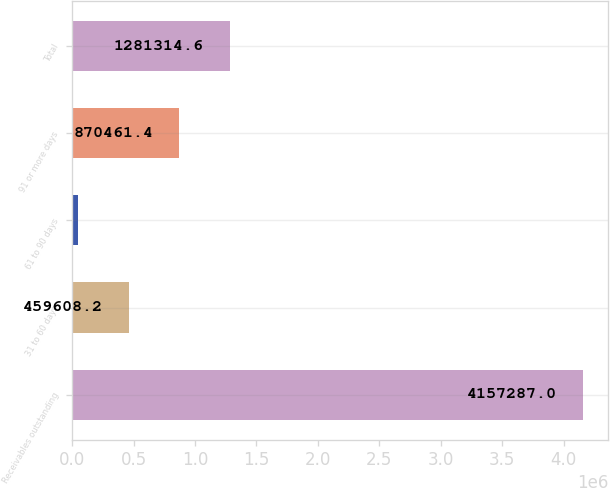Convert chart to OTSL. <chart><loc_0><loc_0><loc_500><loc_500><bar_chart><fcel>Receivables outstanding<fcel>31 to 60 days<fcel>61 to 90 days<fcel>91 or more days<fcel>Total<nl><fcel>4.15729e+06<fcel>459608<fcel>48755<fcel>870461<fcel>1.28131e+06<nl></chart> 